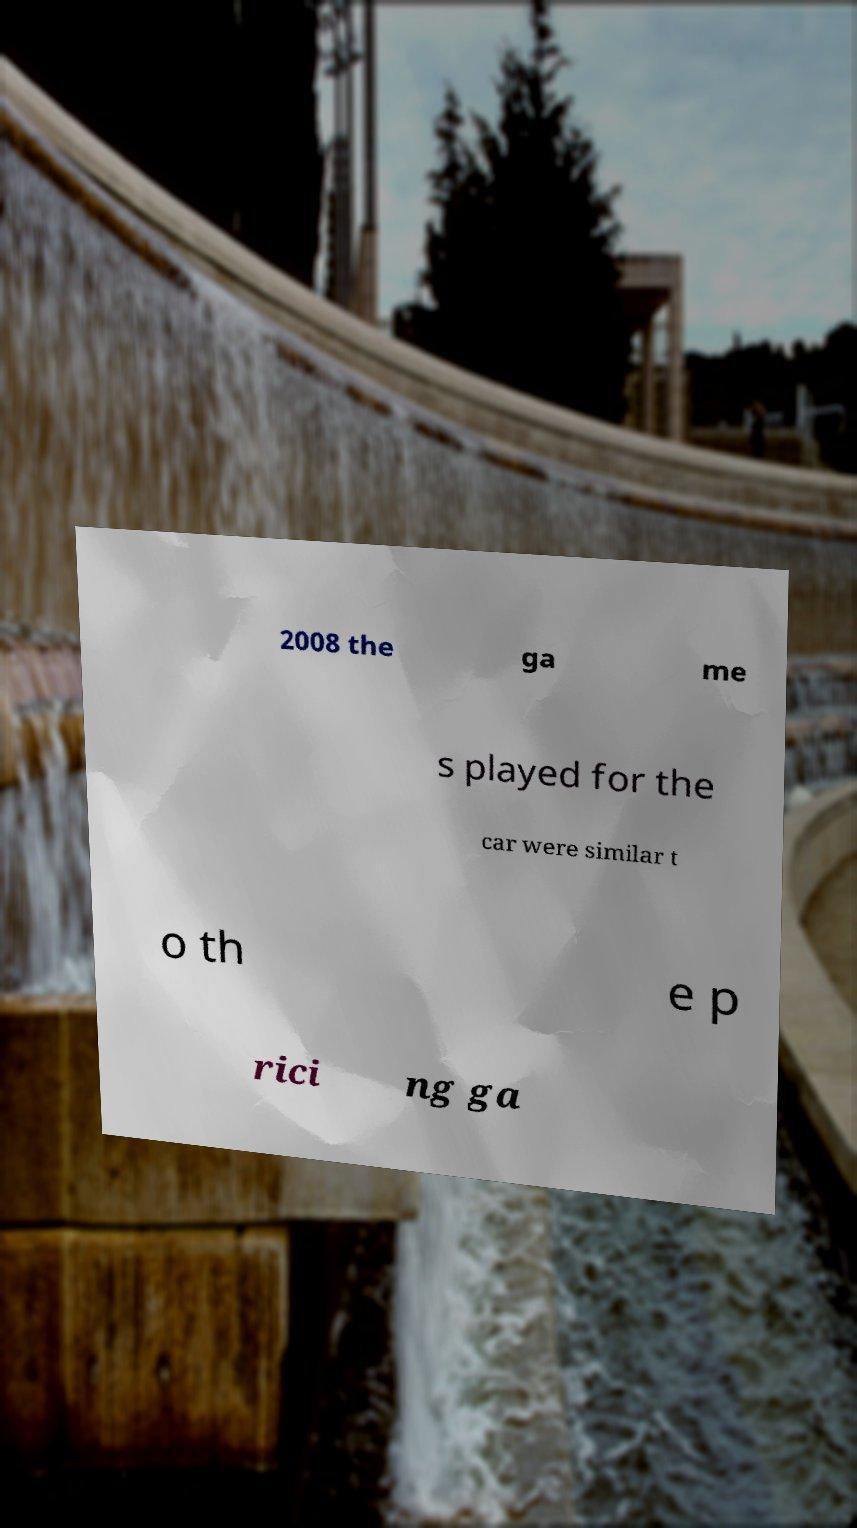Could you extract and type out the text from this image? 2008 the ga me s played for the car were similar t o th e p rici ng ga 